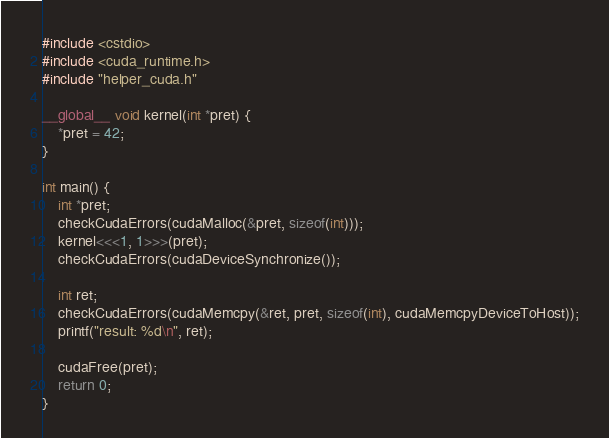<code> <loc_0><loc_0><loc_500><loc_500><_Cuda_>#include <cstdio>
#include <cuda_runtime.h>
#include "helper_cuda.h"

__global__ void kernel(int *pret) {
    *pret = 42;
}

int main() {
    int *pret;
    checkCudaErrors(cudaMalloc(&pret, sizeof(int)));
    kernel<<<1, 1>>>(pret);
    checkCudaErrors(cudaDeviceSynchronize());

    int ret;
    checkCudaErrors(cudaMemcpy(&ret, pret, sizeof(int), cudaMemcpyDeviceToHost));
    printf("result: %d\n", ret);

    cudaFree(pret);
    return 0;
}
</code> 